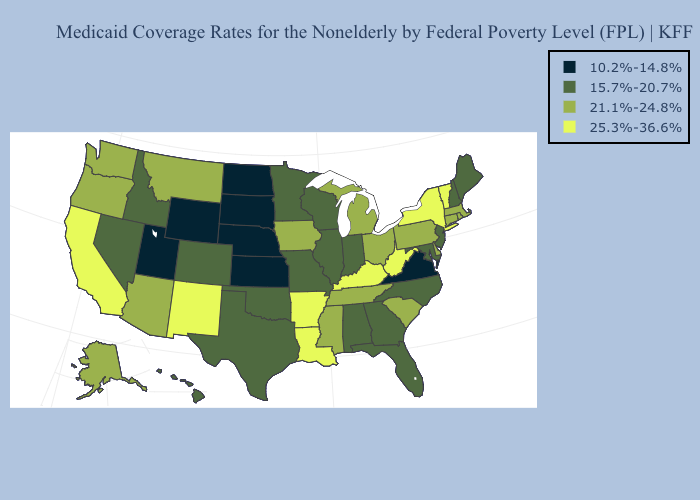What is the value of Texas?
Concise answer only. 15.7%-20.7%. Name the states that have a value in the range 21.1%-24.8%?
Keep it brief. Alaska, Arizona, Connecticut, Delaware, Iowa, Massachusetts, Michigan, Mississippi, Montana, Ohio, Oregon, Pennsylvania, Rhode Island, South Carolina, Tennessee, Washington. Name the states that have a value in the range 15.7%-20.7%?
Answer briefly. Alabama, Colorado, Florida, Georgia, Hawaii, Idaho, Illinois, Indiana, Maine, Maryland, Minnesota, Missouri, Nevada, New Hampshire, New Jersey, North Carolina, Oklahoma, Texas, Wisconsin. Does Washington have the same value as Illinois?
Short answer required. No. Name the states that have a value in the range 10.2%-14.8%?
Short answer required. Kansas, Nebraska, North Dakota, South Dakota, Utah, Virginia, Wyoming. Does Tennessee have the same value as Massachusetts?
Quick response, please. Yes. Name the states that have a value in the range 21.1%-24.8%?
Answer briefly. Alaska, Arizona, Connecticut, Delaware, Iowa, Massachusetts, Michigan, Mississippi, Montana, Ohio, Oregon, Pennsylvania, Rhode Island, South Carolina, Tennessee, Washington. Does Ohio have the lowest value in the MidWest?
Be succinct. No. What is the highest value in the South ?
Be succinct. 25.3%-36.6%. Does Vermont have the highest value in the Northeast?
Give a very brief answer. Yes. Does North Carolina have a higher value than Utah?
Short answer required. Yes. What is the value of Massachusetts?
Quick response, please. 21.1%-24.8%. What is the value of Arizona?
Be succinct. 21.1%-24.8%. Which states hav the highest value in the Northeast?
Be succinct. New York, Vermont. Which states have the lowest value in the USA?
Short answer required. Kansas, Nebraska, North Dakota, South Dakota, Utah, Virginia, Wyoming. 